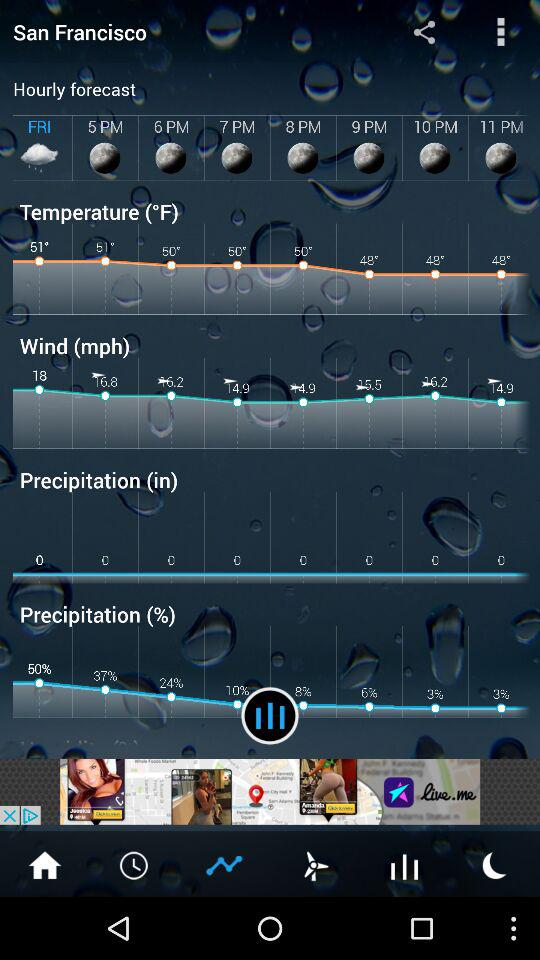What is the location? The location is San Francisco. 